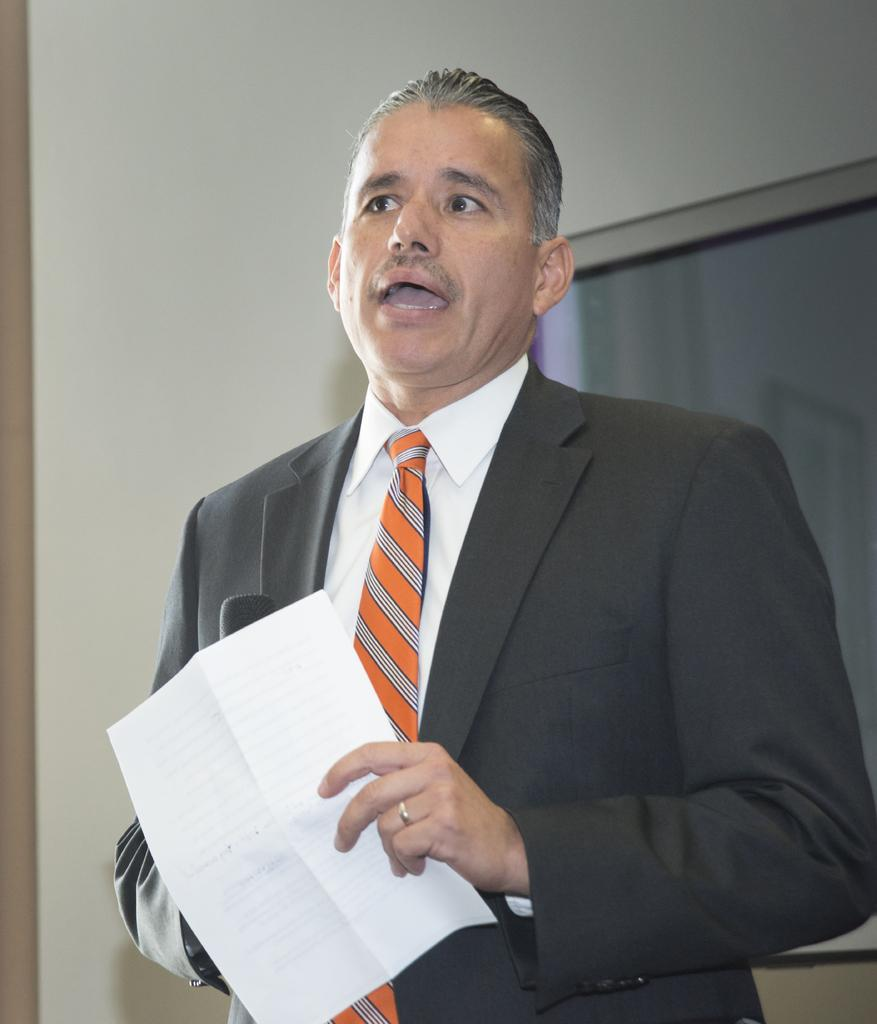Who or what is present in the image? There is a person in the image. What is the person holding? The person is holding a paper. What can be seen in the background of the image? There is a window and walls in the background of the image. Can you taste the sink in the image? There is no sink present in the image, so it is not possible to taste it. 